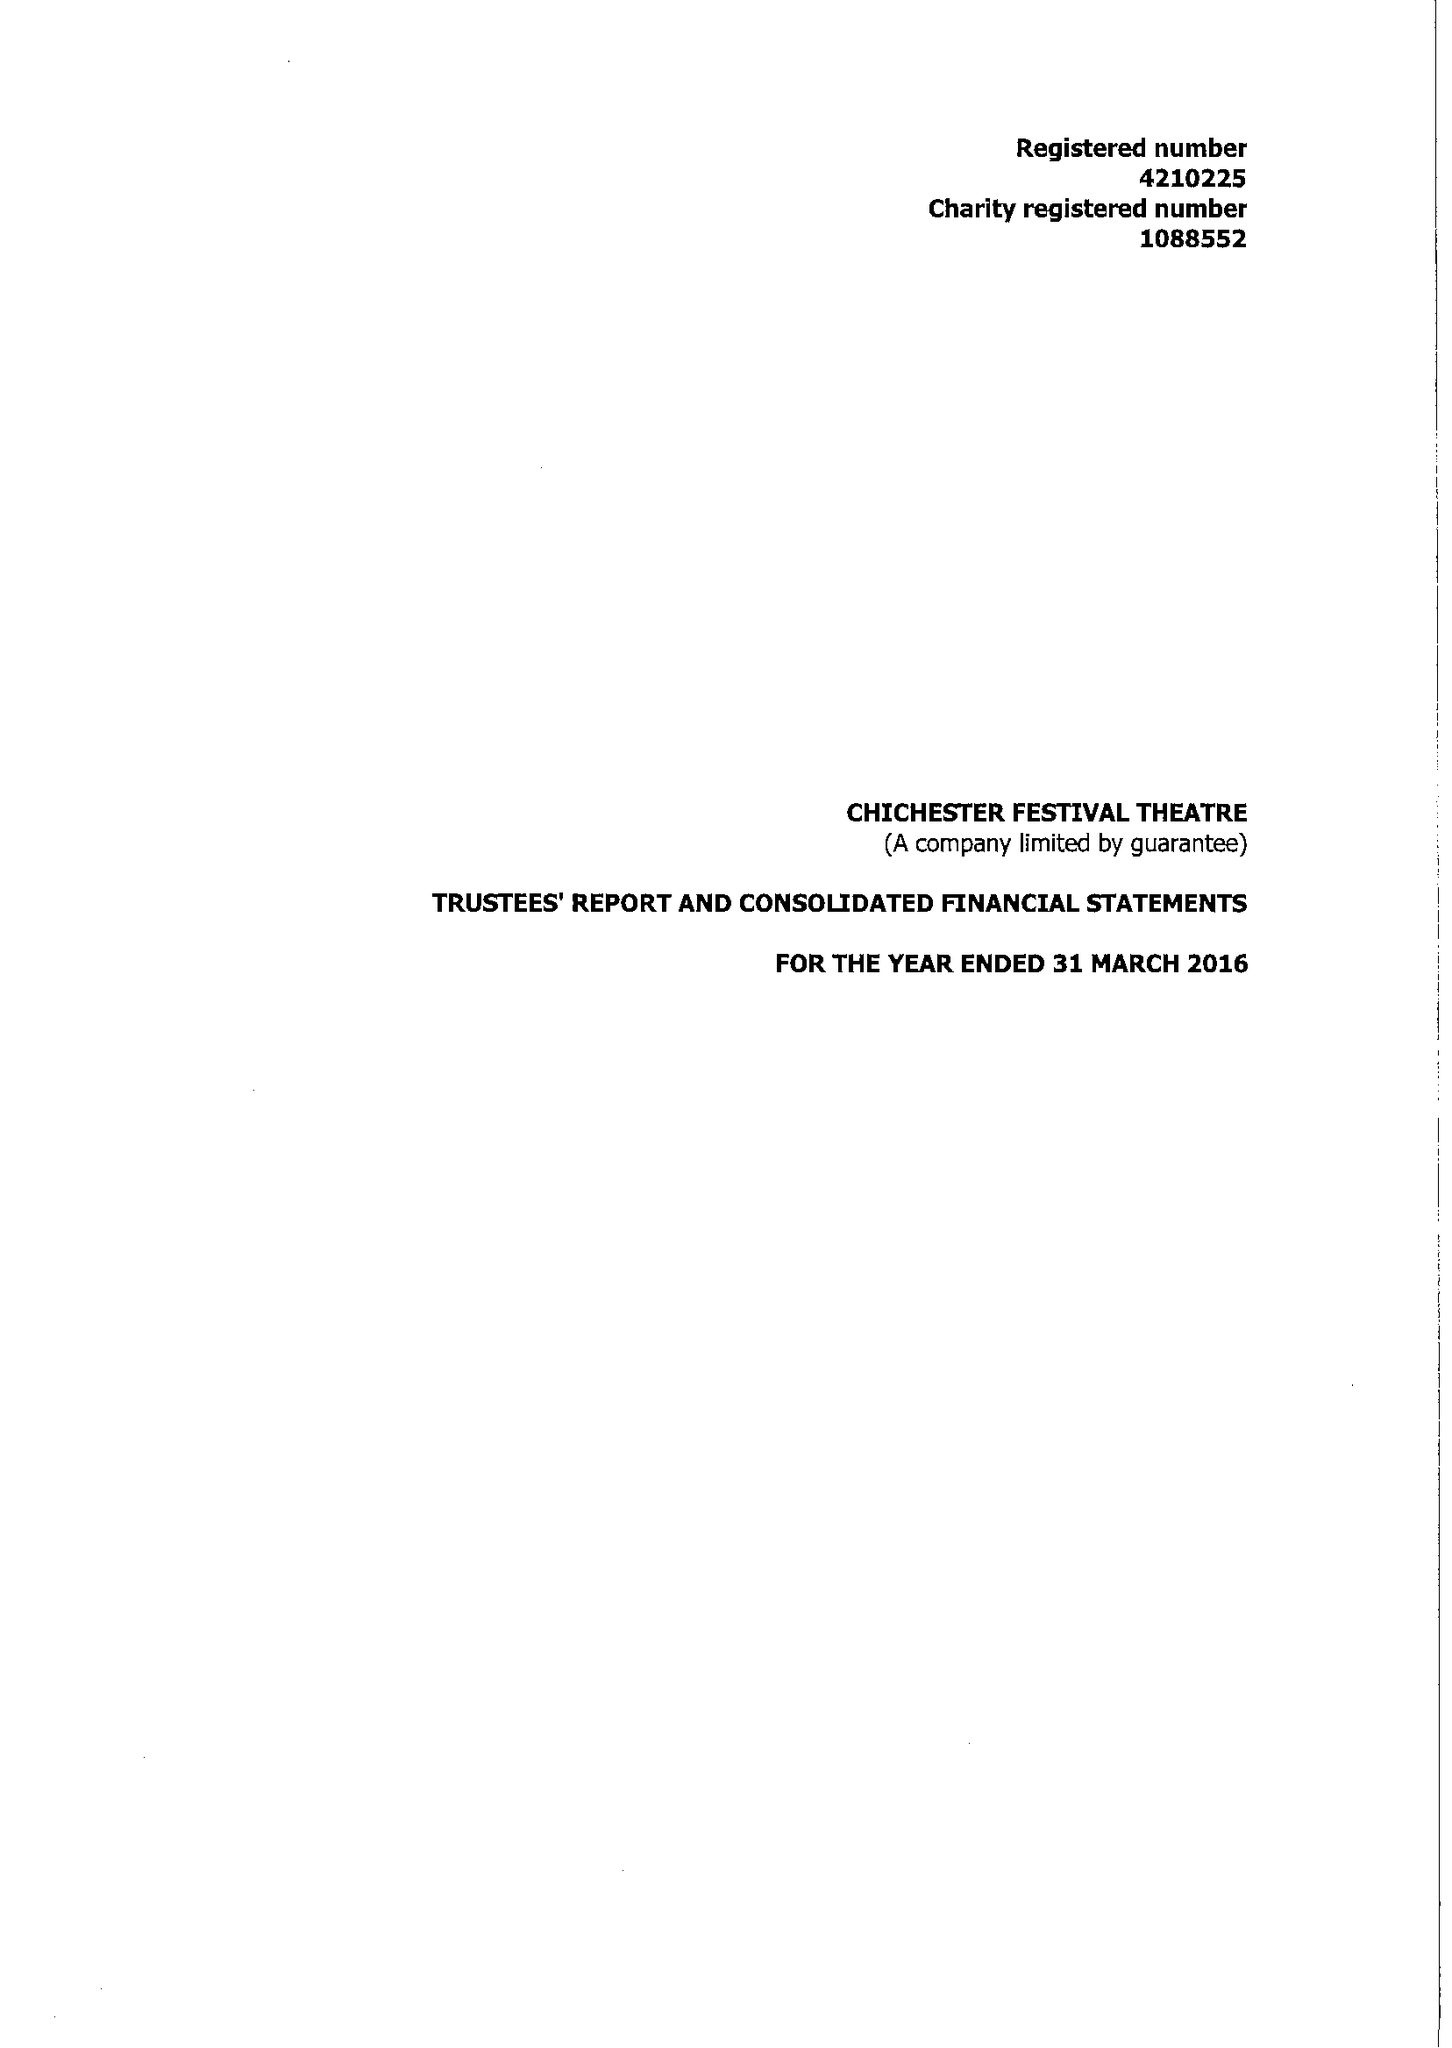What is the value for the report_date?
Answer the question using a single word or phrase. 2016-03-31 